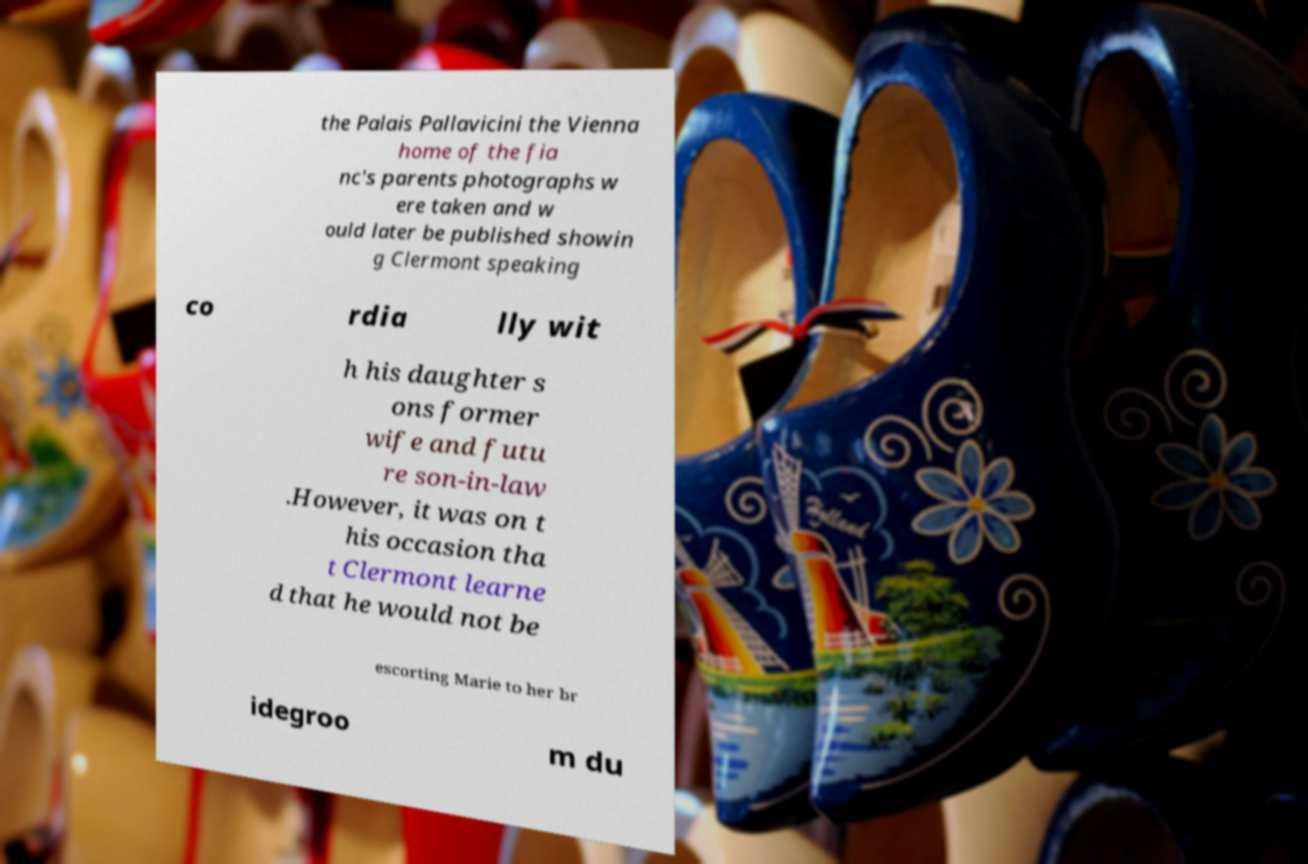There's text embedded in this image that I need extracted. Can you transcribe it verbatim? the Palais Pallavicini the Vienna home of the fia nc's parents photographs w ere taken and w ould later be published showin g Clermont speaking co rdia lly wit h his daughter s ons former wife and futu re son-in-law .However, it was on t his occasion tha t Clermont learne d that he would not be escorting Marie to her br idegroo m du 